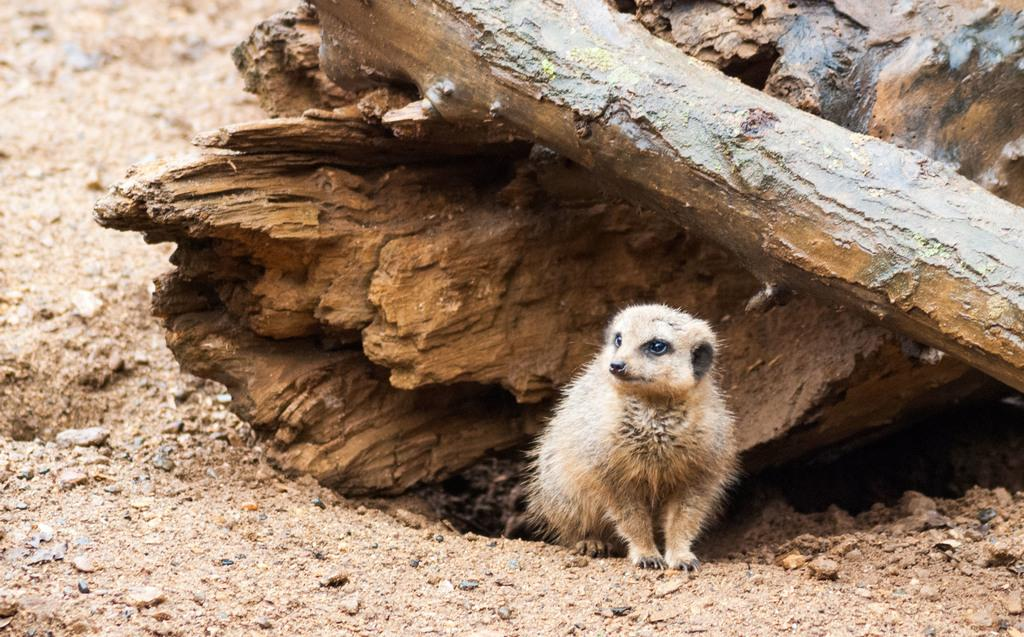What animal is in the image? There is a Meerkat in the image. What is the Meerkat sitting on? The Meerkat is sitting on the sand. What can be seen behind the Meerkat? There is a tree pole behind the Meerkat. What type of hammer is the Meerkat holding in the image? There is no hammer present in the image; the Meerkat is simply sitting on the sand. 